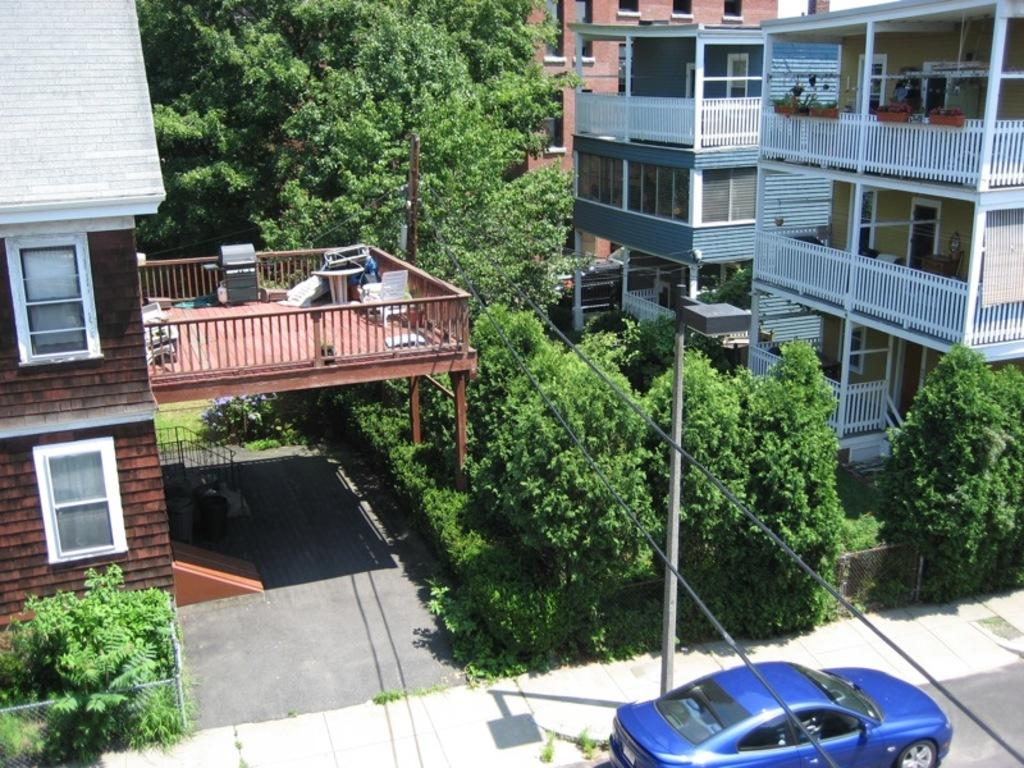What type of structures can be seen in the image? There are buildings in the image. What natural elements are present in the image? There are trees in the image. What architectural features can be observed in the image? There are railings and fences in the image. What is happening on the road in the image? There are vehicles on the road in the image. What is attached to the pole in the image? There are wires attached to the pole in the image. Can you tell me how many needles are attached to the fence in the image? There are no needles present in the image; it features buildings, trees, railings, fences, vehicles, and a pole with wires. What type of thing is the visitor holding in the image? There is no visitor present in the image, so it is not possible to determine what they might be holding. 